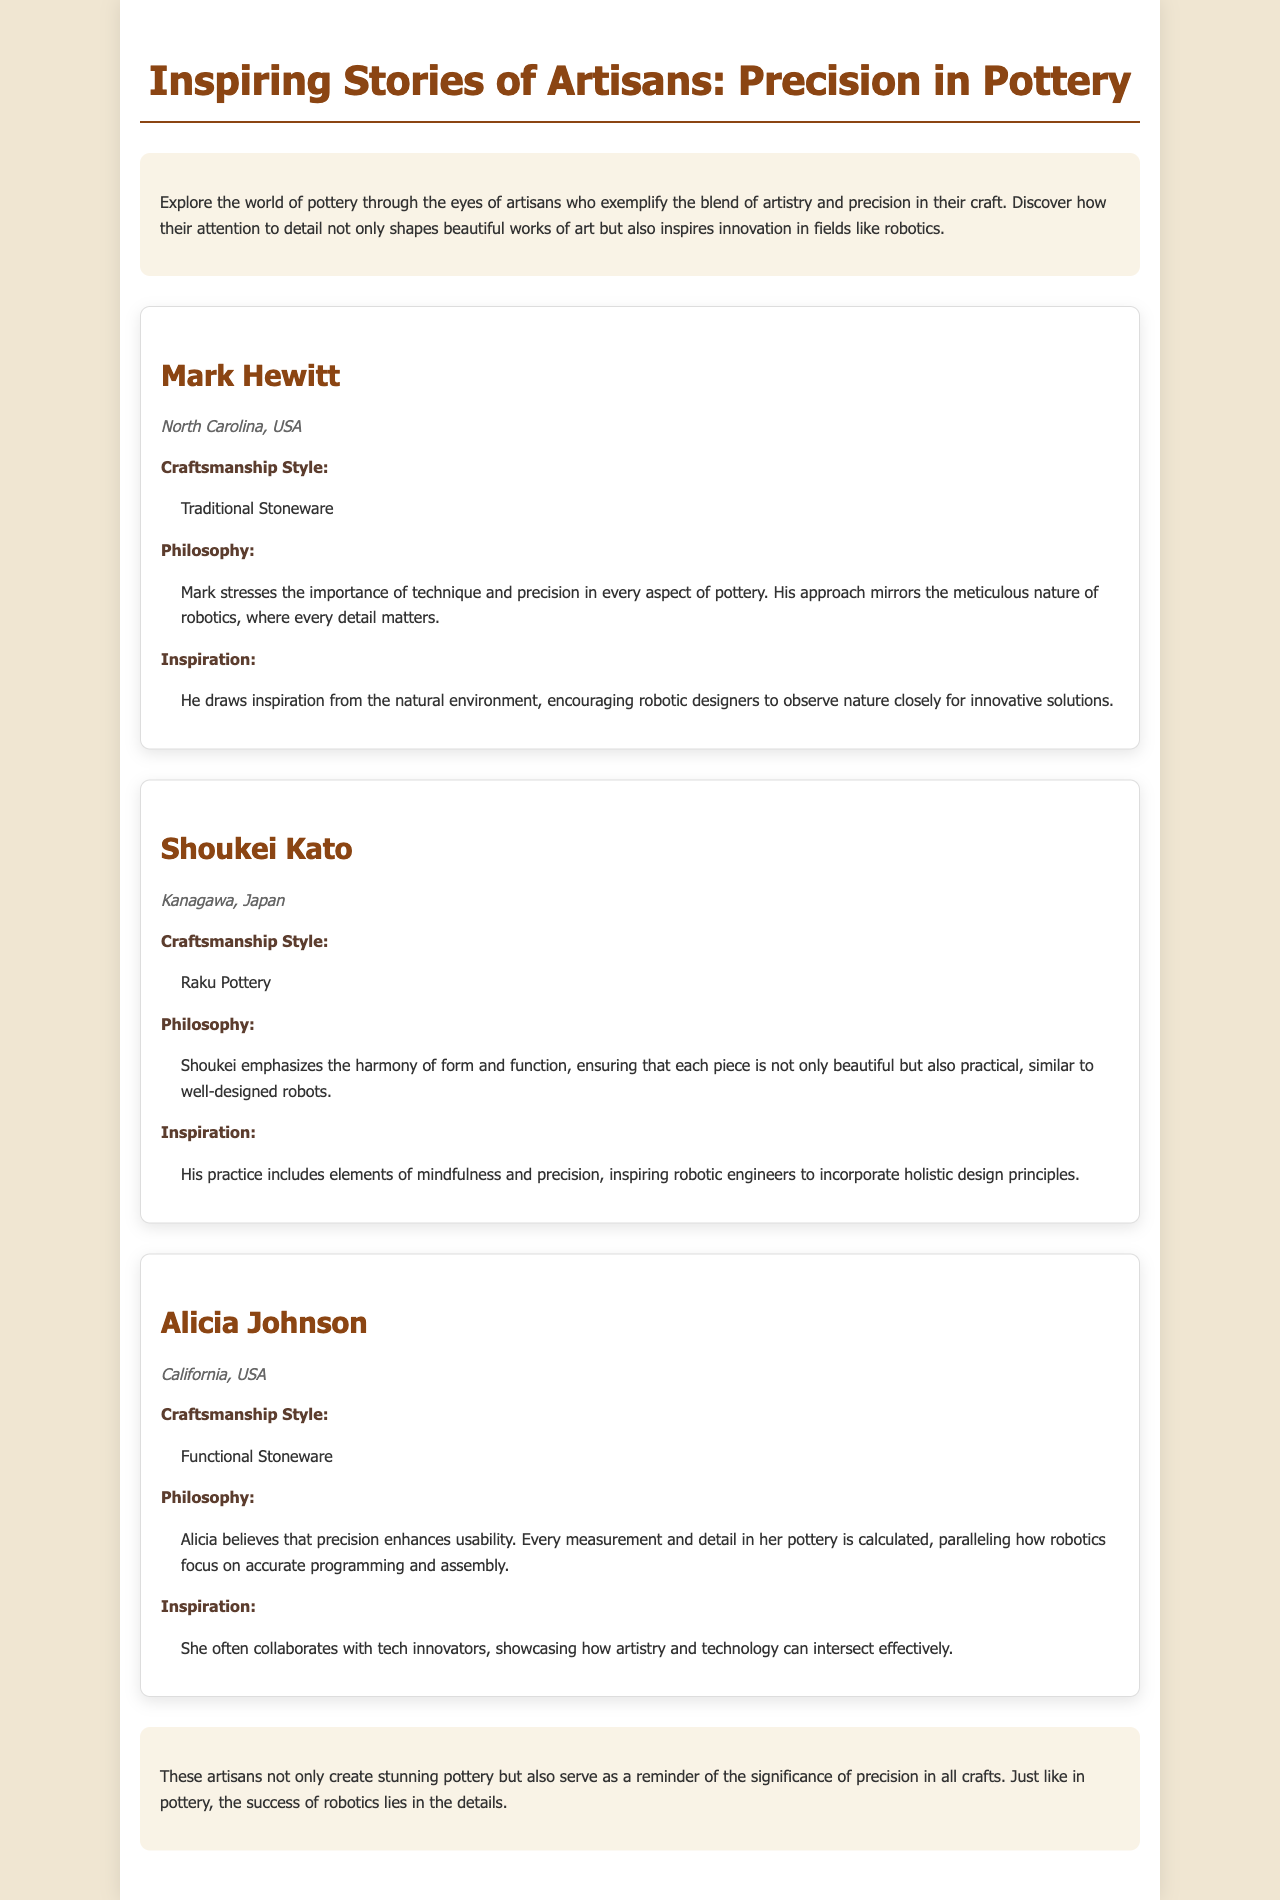What is the title of the brochure? The title is found at the top of the document, showcasing the main theme of the content.
Answer: Inspiring Stories of Artisans: Precision in Pottery Who is the potter from North Carolina? The document lists individual profiles of potters, including their names and locations.
Answer: Mark Hewitt What craftsmanship style does Shoukei Kato emphasize? The craftsmanship style is specifically mentioned in Shoukei Kato's profile.
Answer: Raku Pottery What philosophy does Alicia Johnson believe in regarding precision? Alicia's philosophy regarding precision is outlined in her section along with its significance.
Answer: Precision enhances usability How many potters are featured in the document? This can be determined by counting the individual potter profiles presented in the document.
Answer: Three What type of pottery does Mark Hewitt specialize in? The type of pottery is clearly stated in his profile under craftsmanship style.
Answer: Traditional Stoneware Which potter collaborates with tech innovators? The document indicates collaboration efforts as part of this potter's inspiration.
Answer: Alicia Johnson What is a common theme in the lessons from the profiles? The conclusion summarizes the document’s message regarding techniques shared by the featured potters.
Answer: Precision in all crafts 